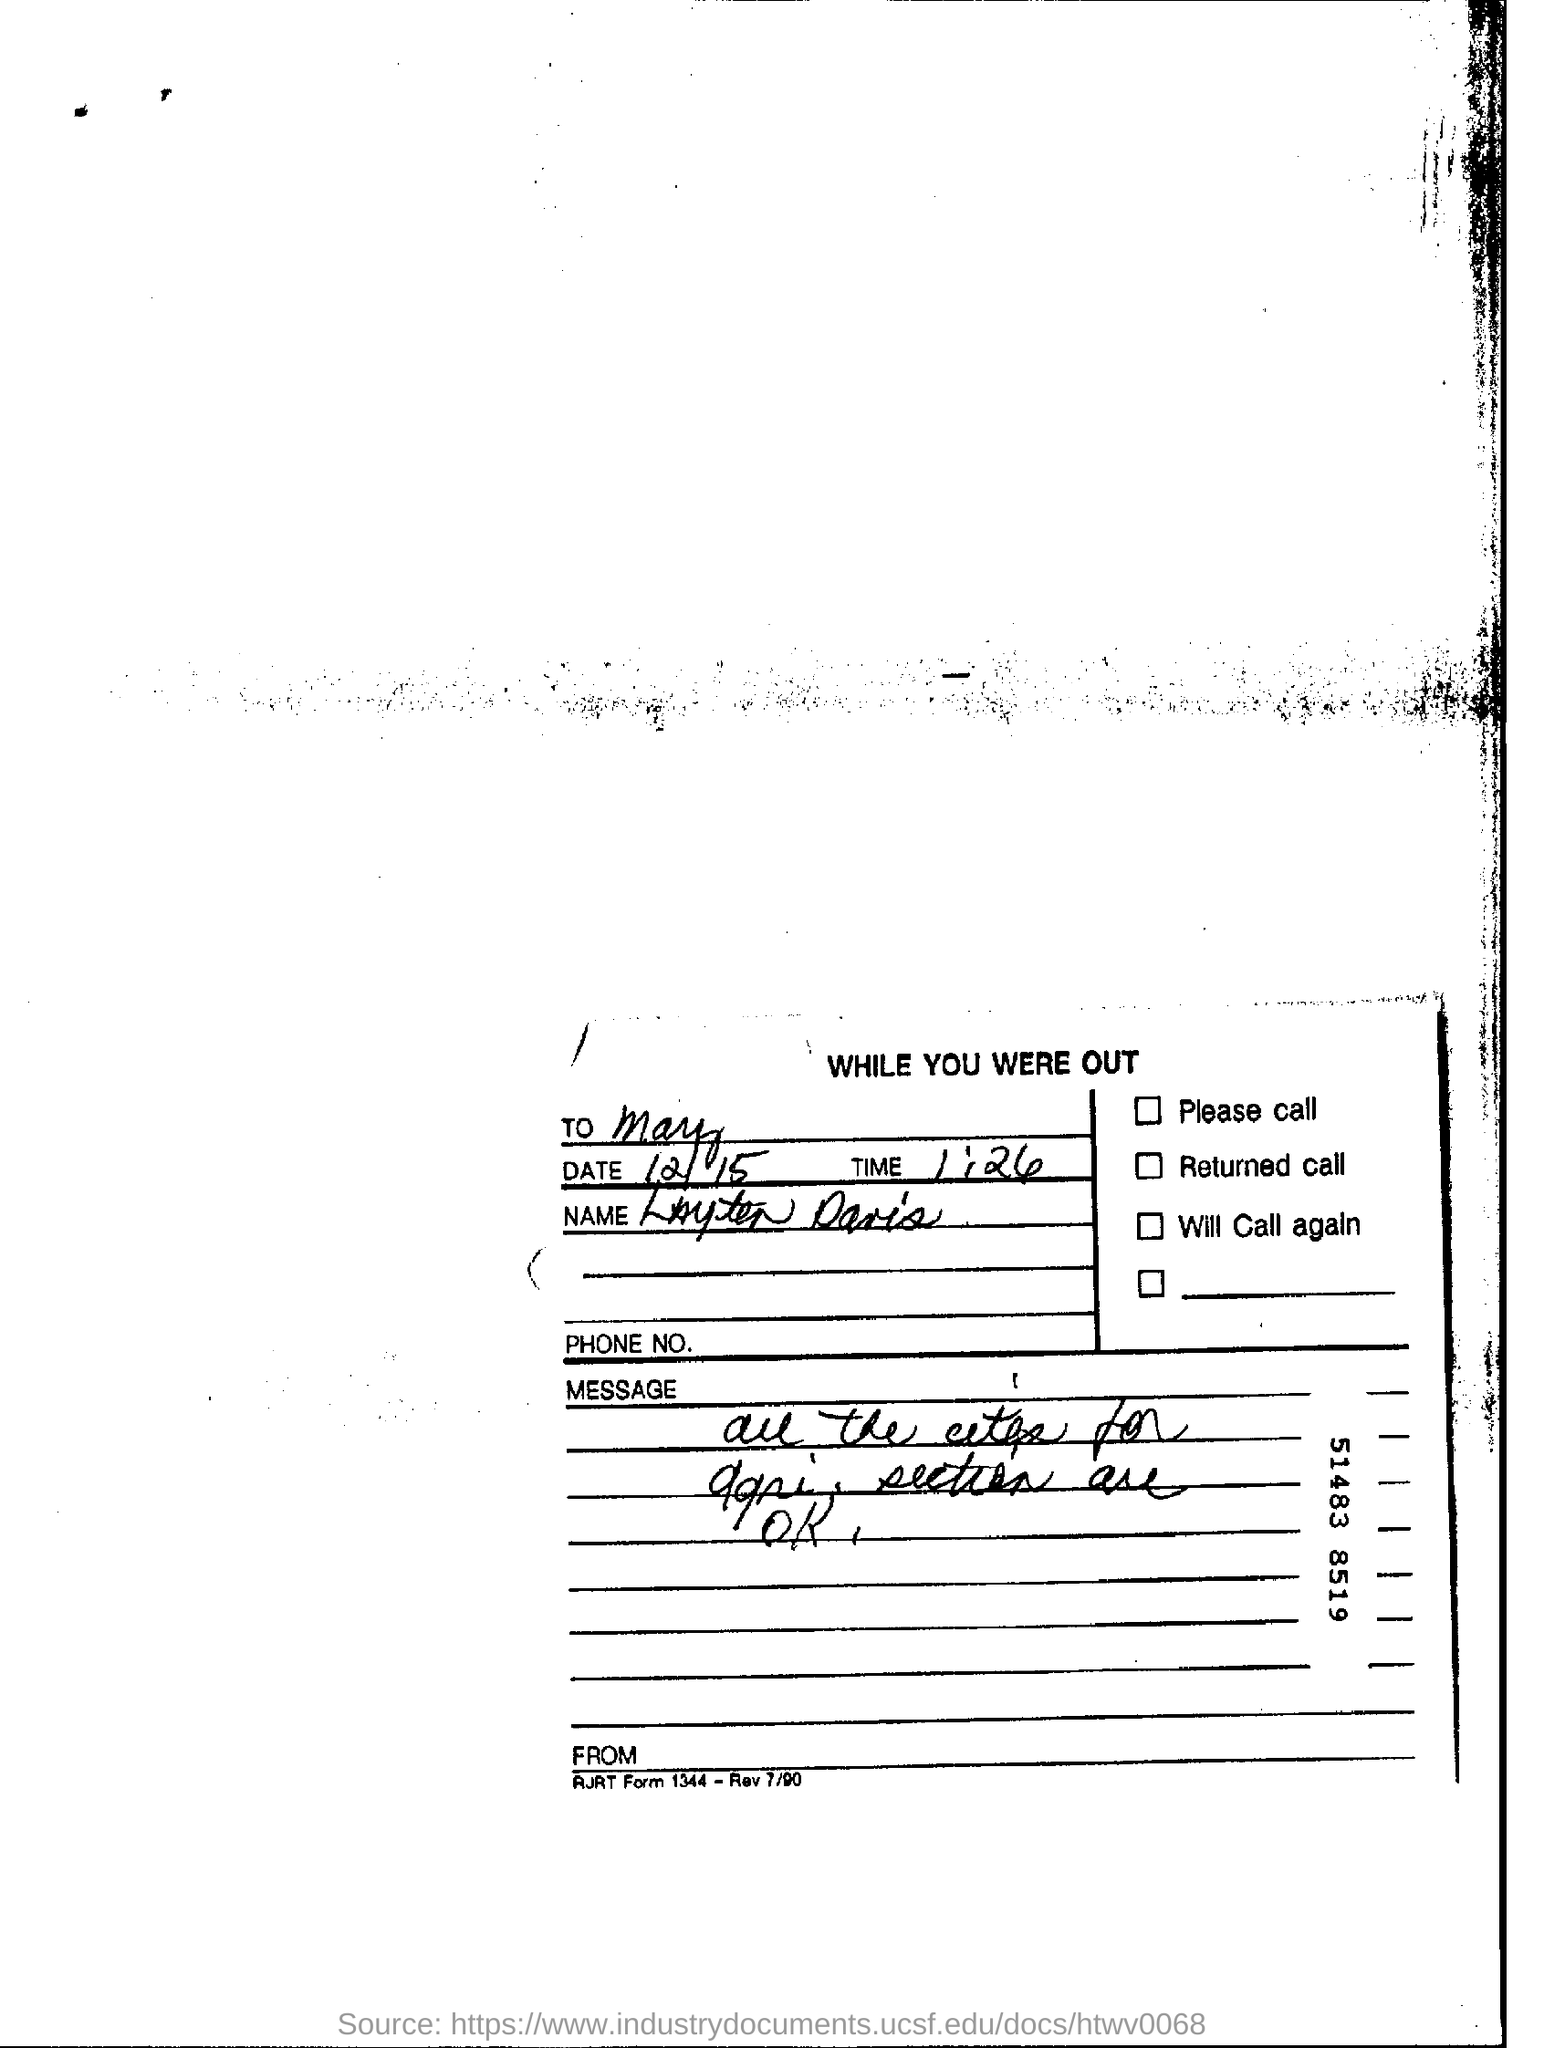Highlight a few significant elements in this photo. The date mentioned is December 15. The heading of the document is "What is the heading of the document? while you were out..". The time mentioned is 1:26. 